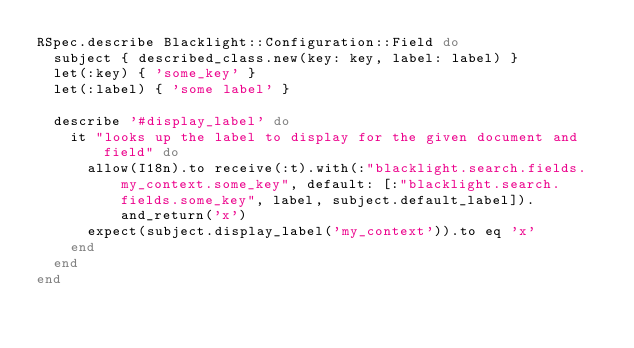<code> <loc_0><loc_0><loc_500><loc_500><_Ruby_>RSpec.describe Blacklight::Configuration::Field do
  subject { described_class.new(key: key, label: label) }
  let(:key) { 'some_key' }
  let(:label) { 'some label' }

  describe '#display_label' do
    it "looks up the label to display for the given document and field" do
      allow(I18n).to receive(:t).with(:"blacklight.search.fields.my_context.some_key", default: [:"blacklight.search.fields.some_key", label, subject.default_label]).and_return('x')
      expect(subject.display_label('my_context')).to eq 'x'
    end
  end
end
</code> 